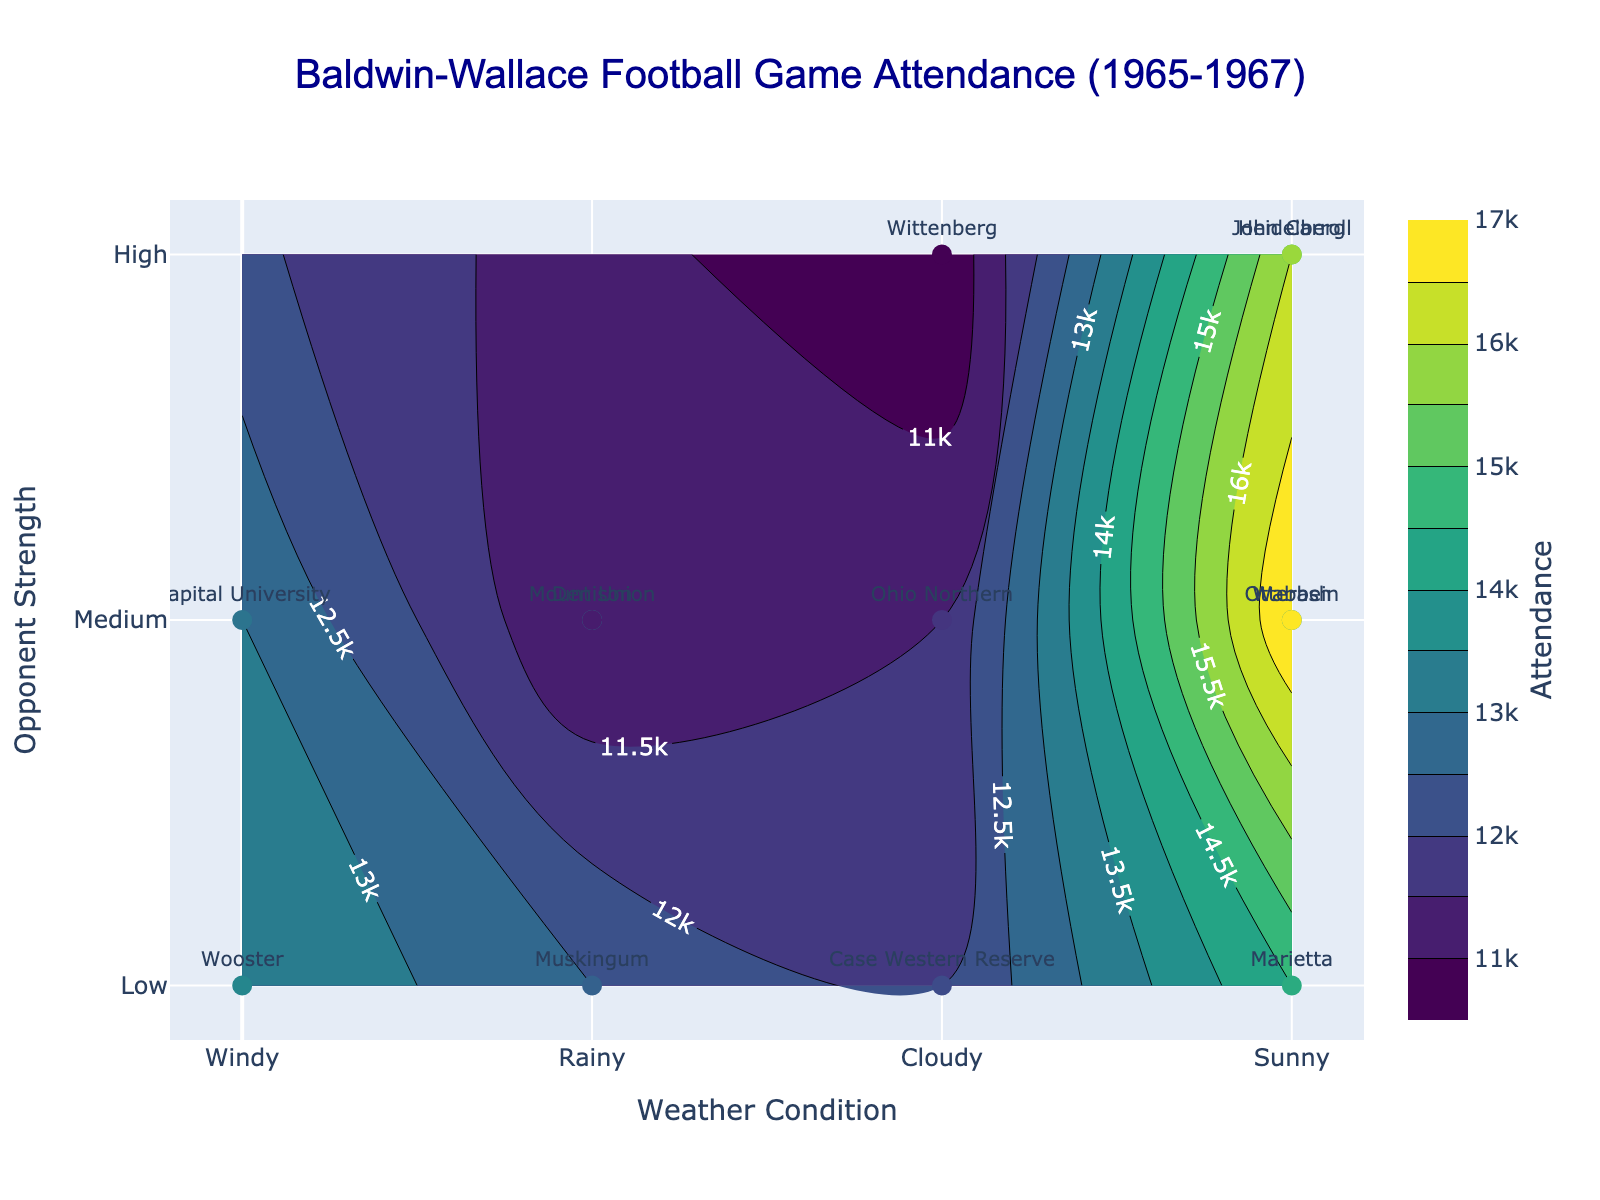What is the title of the contour plot? The title is generally found at the top of the plot. For this figure, it is "Baldwin-Wallace Football Game Attendance (1965-1967)"
Answer: Baldwin-Wallace Football Game Attendance (1965-1967) How many different weather conditions are represented on the x-axis? The x-axis shows the weather conditions mapped to numeric values. There are four tick texts: "Windy," "Rainy," "Cloudy," and "Sunny."
Answer: 4 Which opponent had the highest attendance and what was the weather condition? First, look for the data point with the highest numeric value on the color scale. The highest attendance figure is 17000 for the Otterbein game, which occurred under 'Sunny' conditions.
Answer: Otterbein, Sunny What color represents the highest attendance on the contour plot? Identify the color corresponding to the highest value on the color scale. The color for the highest attendance is a bright yellow or gold on the Viridis color scale.
Answer: Bright yellow/gold How does attendance vary with weather condition when the opponent strength is medium? Observe the contour lines or color changes along the weather condition axis (x-axis) where the opponent strength is medium (y-axis = 2). The contour lines show that attendance is generally higher in 'Sunny' weather and lower in 'Rainy' or 'Cloudy' conditions.
Answer: Higher in Sunny Which weather condition correlates with the lowest attendance for a medium strength opponent? Look along the x-axis where the opponent strength is medium (y=2) and locate the lowest attendance contour or color. The lowest attendance is under 'Rainy' conditions.
Answer: Rainy Identify the game with the lowest attendance and give the opponent's strength and weather condition? Locate the data point with the lowest attendance on the color scale. The Wittenberg game has the lowest attendance (10500) under 'Cloudy' conditions, with a 'High' opponent strength.
Answer: Wittenberg, High, Cloudy What is the overall trend between weather conditions and attendance for games with low strength opponents? Inspect the contour patterns along the weather condition axis (x-axis) where opponent strength is low (y-axis = 1). The contour lines indicate a slight increase in attendance from 'Rainy' to 'Sunny' weather.
Answer: Increasing trend Which opponent had the highest attendance under 'Rainy' conditions? Check data points categorized under 'Rainy' (WeatherNumeric=1) and identify which has the highest attendance value. 'John Carroll' had the highest attendance (15000) under 'Rainy' conditions.
Answer: John Carroll What is the typical attendance level for games played in 'Cloudy' conditions regardless of opponent strength? Examine the contour lines or color intensity along the 'Cloudy' weather condition (x=2) and average the corresponding attendance levels. The attendance is generally in the low to medium range, around 11500-12000.
Answer: Low to medium, 11500-12000 